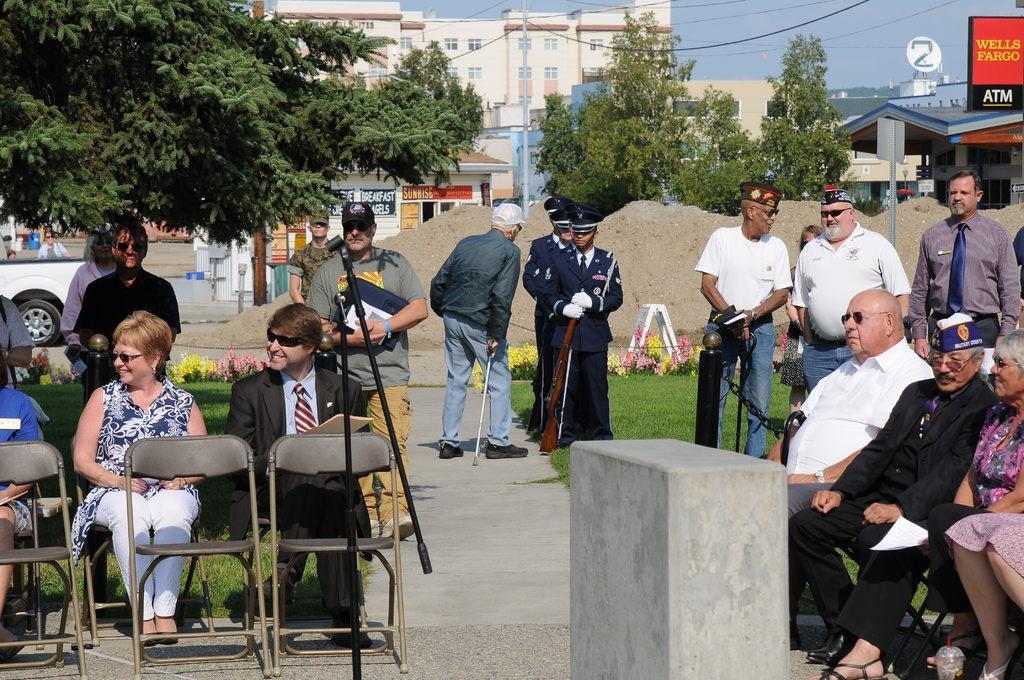Please provide a concise description of this image. In this image we can see a group of people standing on the ground. In that some people are sitting on the chairs and a person is holding the stand of a camera. We can also see some grass, plants with flowers, some empty chairs, a stool, heap of sand, a car, a group of trees and a house with a roof. On the backside we can see some buildings with windows, wires and the sky which look cloudy. 